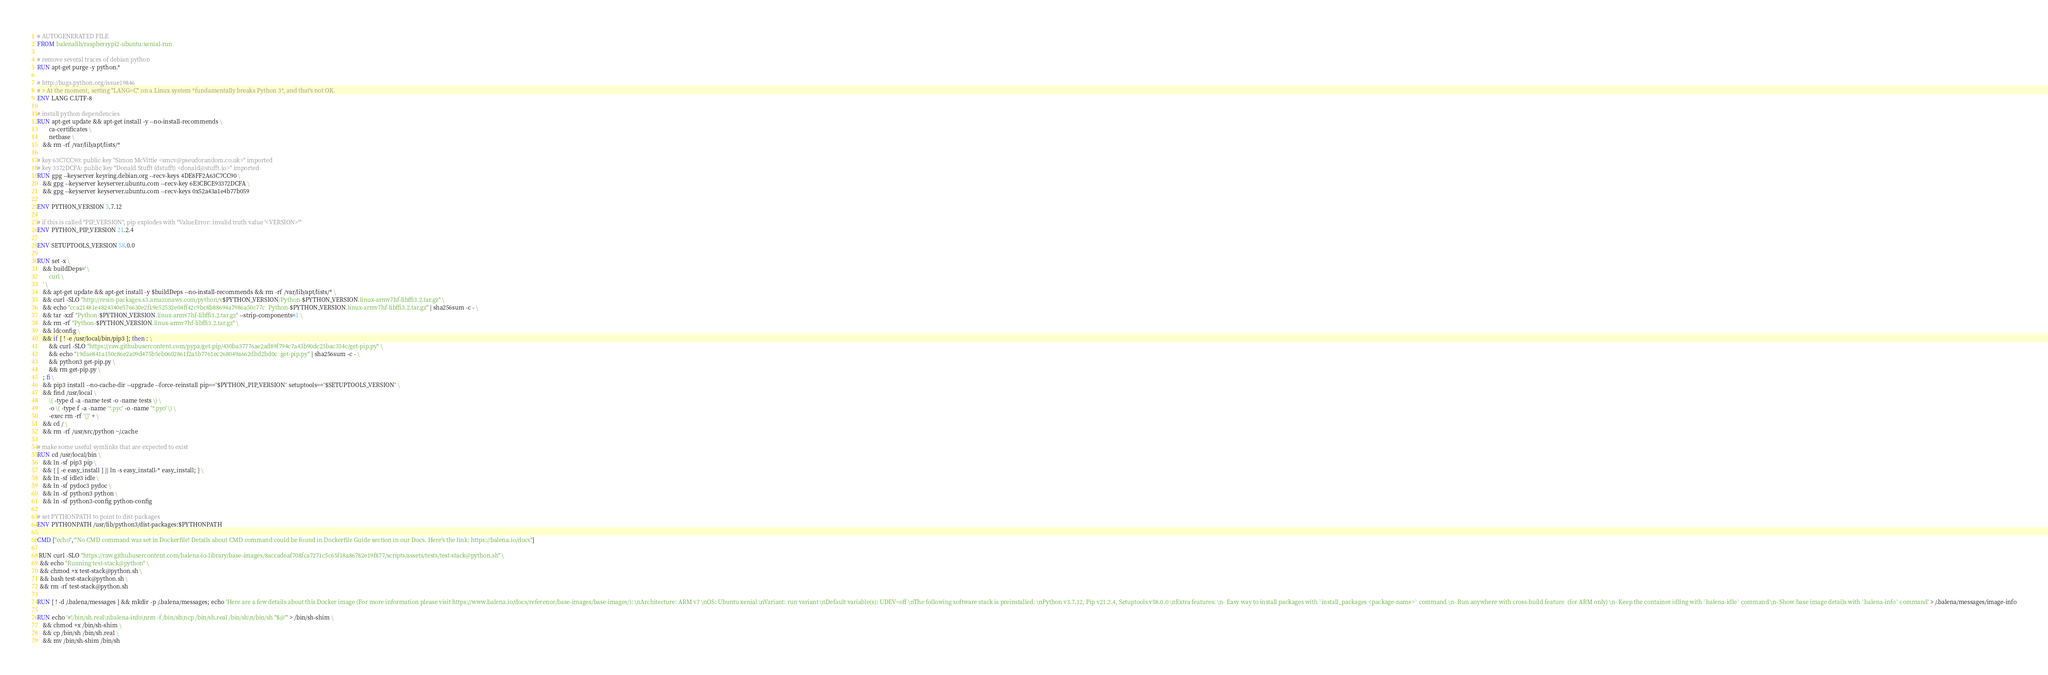Convert code to text. <code><loc_0><loc_0><loc_500><loc_500><_Dockerfile_># AUTOGENERATED FILE
FROM balenalib/raspberrypi2-ubuntu:xenial-run

# remove several traces of debian python
RUN apt-get purge -y python.*

# http://bugs.python.org/issue19846
# > At the moment, setting "LANG=C" on a Linux system *fundamentally breaks Python 3*, and that's not OK.
ENV LANG C.UTF-8

# install python dependencies
RUN apt-get update && apt-get install -y --no-install-recommends \
		ca-certificates \
		netbase \
	&& rm -rf /var/lib/apt/lists/*

# key 63C7CC90: public key "Simon McVittie <smcv@pseudorandom.co.uk>" imported
# key 3372DCFA: public key "Donald Stufft (dstufft) <donald@stufft.io>" imported
RUN gpg --keyserver keyring.debian.org --recv-keys 4DE8FF2A63C7CC90 \
	&& gpg --keyserver keyserver.ubuntu.com --recv-key 6E3CBCE93372DCFA \
	&& gpg --keyserver keyserver.ubuntu.com --recv-keys 0x52a43a1e4b77b059

ENV PYTHON_VERSION 3.7.12

# if this is called "PIP_VERSION", pip explodes with "ValueError: invalid truth value '<VERSION>'"
ENV PYTHON_PIP_VERSION 21.2.4

ENV SETUPTOOLS_VERSION 58.0.0

RUN set -x \
	&& buildDeps=' \
		curl \
	' \
	&& apt-get update && apt-get install -y $buildDeps --no-install-recommends && rm -rf /var/lib/apt/lists/* \
	&& curl -SLO "http://resin-packages.s3.amazonaws.com/python/v$PYTHON_VERSION/Python-$PYTHON_VERSION.linux-armv7hf-libffi3.2.tar.gz" \
	&& echo "cca21481e4824340e576630e2f19e52532e04ff42c9bc8b88694a7986a50c77c  Python-$PYTHON_VERSION.linux-armv7hf-libffi3.2.tar.gz" | sha256sum -c - \
	&& tar -xzf "Python-$PYTHON_VERSION.linux-armv7hf-libffi3.2.tar.gz" --strip-components=1 \
	&& rm -rf "Python-$PYTHON_VERSION.linux-armv7hf-libffi3.2.tar.gz" \
	&& ldconfig \
	&& if [ ! -e /usr/local/bin/pip3 ]; then : \
		&& curl -SLO "https://raw.githubusercontent.com/pypa/get-pip/430ba37776ae2ad89f794c7a43b90dc23bac334c/get-pip.py" \
		&& echo "19dae841a150c86e2a09d475b5eb0602861f2a5b7761ec268049a662dbd2bd0c  get-pip.py" | sha256sum -c - \
		&& python3 get-pip.py \
		&& rm get-pip.py \
	; fi \
	&& pip3 install --no-cache-dir --upgrade --force-reinstall pip=="$PYTHON_PIP_VERSION" setuptools=="$SETUPTOOLS_VERSION" \
	&& find /usr/local \
		\( -type d -a -name test -o -name tests \) \
		-o \( -type f -a -name '*.pyc' -o -name '*.pyo' \) \
		-exec rm -rf '{}' + \
	&& cd / \
	&& rm -rf /usr/src/python ~/.cache

# make some useful symlinks that are expected to exist
RUN cd /usr/local/bin \
	&& ln -sf pip3 pip \
	&& { [ -e easy_install ] || ln -s easy_install-* easy_install; } \
	&& ln -sf idle3 idle \
	&& ln -sf pydoc3 pydoc \
	&& ln -sf python3 python \
	&& ln -sf python3-config python-config

# set PYTHONPATH to point to dist-packages
ENV PYTHONPATH /usr/lib/python3/dist-packages:$PYTHONPATH

CMD ["echo","'No CMD command was set in Dockerfile! Details about CMD command could be found in Dockerfile Guide section in our Docs. Here's the link: https://balena.io/docs"]

 RUN curl -SLO "https://raw.githubusercontent.com/balena-io-library/base-images/8accad6af708fca7271c5c65f18a86782e19f877/scripts/assets/tests/test-stack@python.sh" \
  && echo "Running test-stack@python" \
  && chmod +x test-stack@python.sh \
  && bash test-stack@python.sh \
  && rm -rf test-stack@python.sh 

RUN [ ! -d /.balena/messages ] && mkdir -p /.balena/messages; echo 'Here are a few details about this Docker image (For more information please visit https://www.balena.io/docs/reference/base-images/base-images/): \nArchitecture: ARM v7 \nOS: Ubuntu xenial \nVariant: run variant \nDefault variable(s): UDEV=off \nThe following software stack is preinstalled: \nPython v3.7.12, Pip v21.2.4, Setuptools v58.0.0 \nExtra features: \n- Easy way to install packages with `install_packages <package-name>` command \n- Run anywhere with cross-build feature  (for ARM only) \n- Keep the container idling with `balena-idle` command \n- Show base image details with `balena-info` command' > /.balena/messages/image-info

RUN echo '#!/bin/sh.real\nbalena-info\nrm -f /bin/sh\ncp /bin/sh.real /bin/sh\n/bin/sh "$@"' > /bin/sh-shim \
	&& chmod +x /bin/sh-shim \
	&& cp /bin/sh /bin/sh.real \
	&& mv /bin/sh-shim /bin/sh</code> 